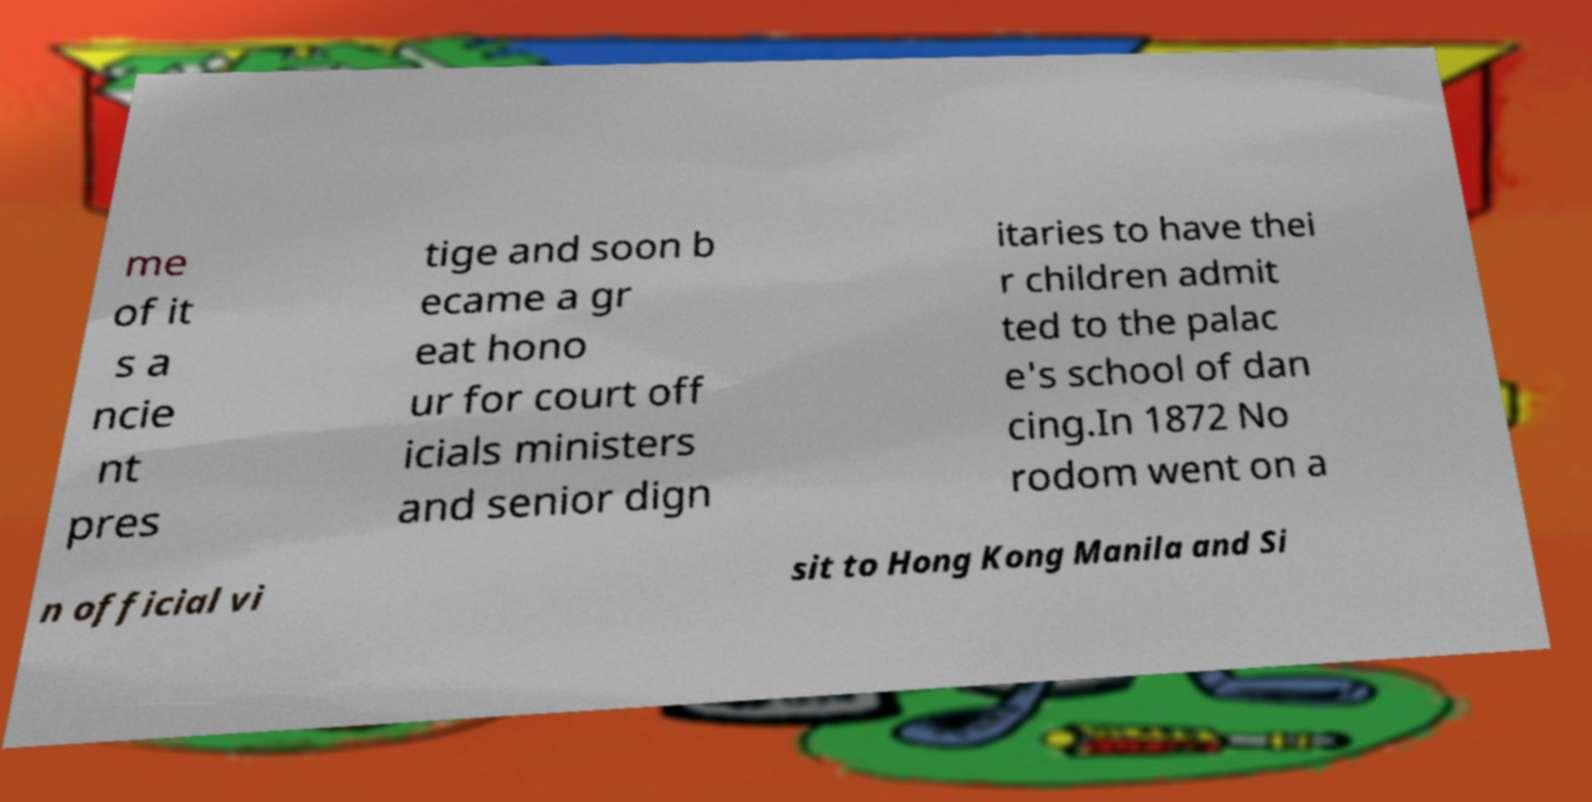Can you read and provide the text displayed in the image?This photo seems to have some interesting text. Can you extract and type it out for me? me of it s a ncie nt pres tige and soon b ecame a gr eat hono ur for court off icials ministers and senior dign itaries to have thei r children admit ted to the palac e's school of dan cing.In 1872 No rodom went on a n official vi sit to Hong Kong Manila and Si 